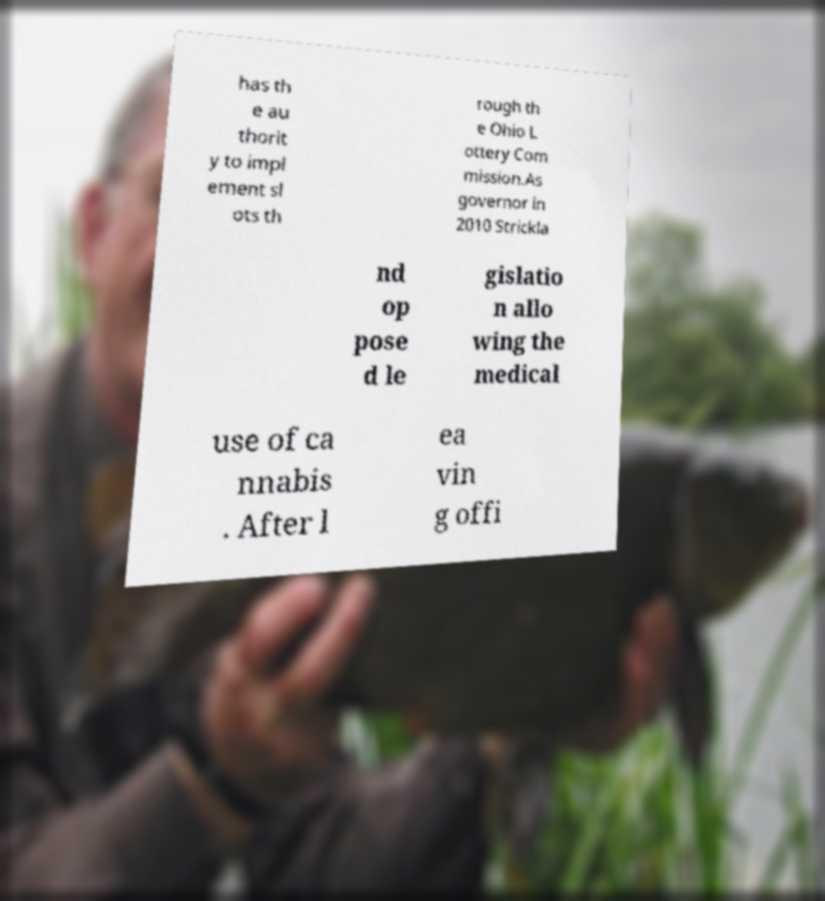There's text embedded in this image that I need extracted. Can you transcribe it verbatim? has th e au thorit y to impl ement sl ots th rough th e Ohio L ottery Com mission.As governor in 2010 Strickla nd op pose d le gislatio n allo wing the medical use of ca nnabis . After l ea vin g offi 